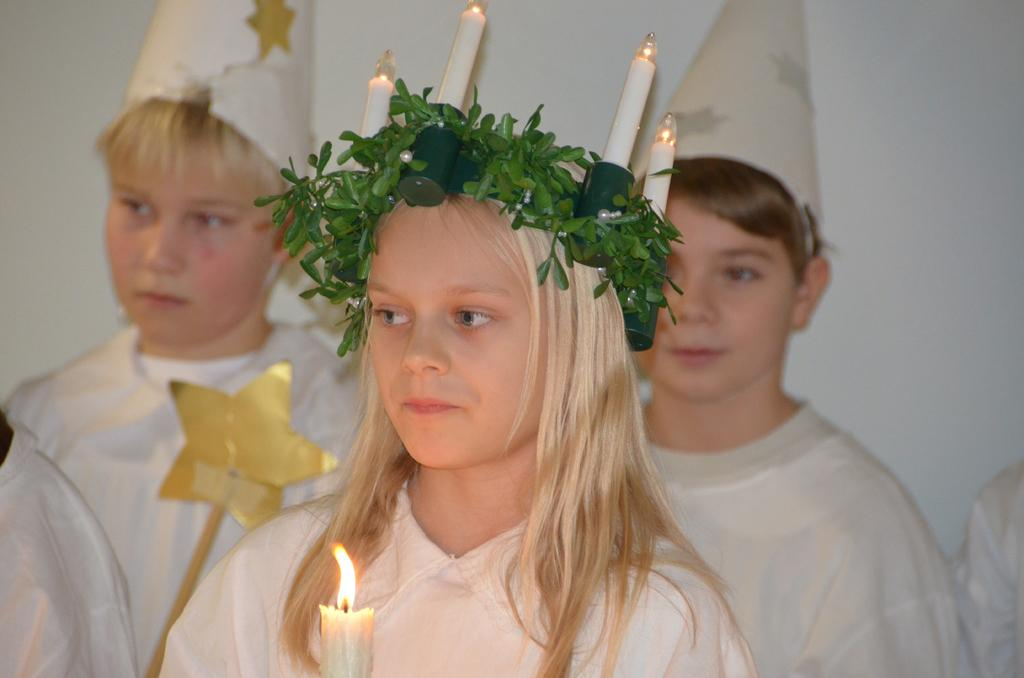How many people are in the image? There are three persons in the image. What is the girl holding in the image? The girl is holding a candle in the image. What can be seen illuminating the scene in the image? There are lights visible in the image. What type of vegetation is present in the image? Leaves are present in the image. What is visible in the background of the image? There is a wall in the background of the image. What type of eggnog can be seen being served in the image? There is no eggnog present in the image. Can you tell me how many grains of sand are visible on the ground in the image? There is no sand visible in the image. 